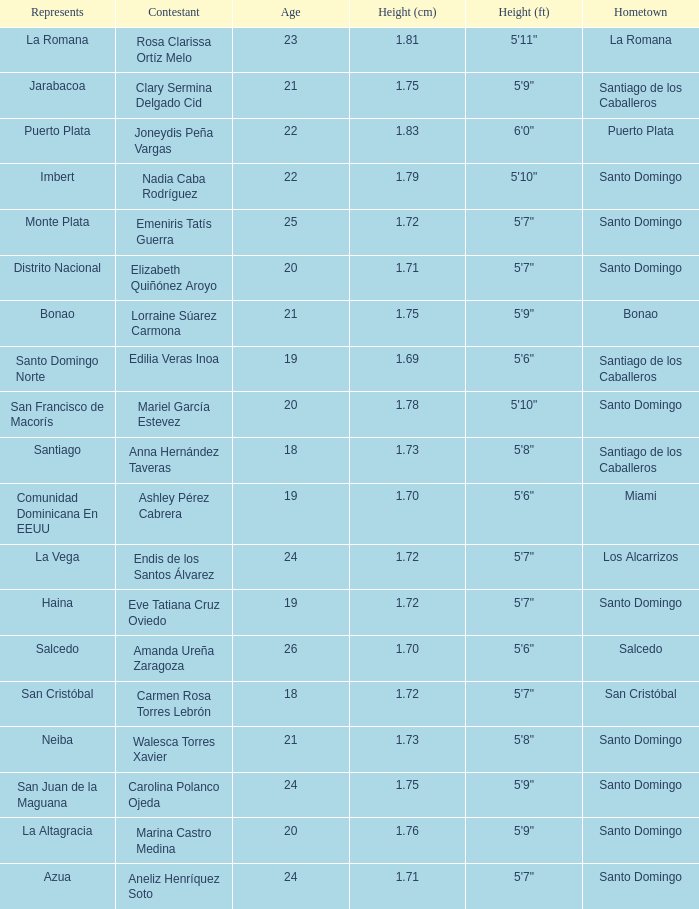Name the least age for distrito nacional 20.0. 